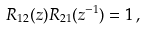Convert formula to latex. <formula><loc_0><loc_0><loc_500><loc_500>R _ { 1 2 } ( z ) R _ { 2 1 } ( z ^ { - 1 } ) = 1 \, ,</formula> 